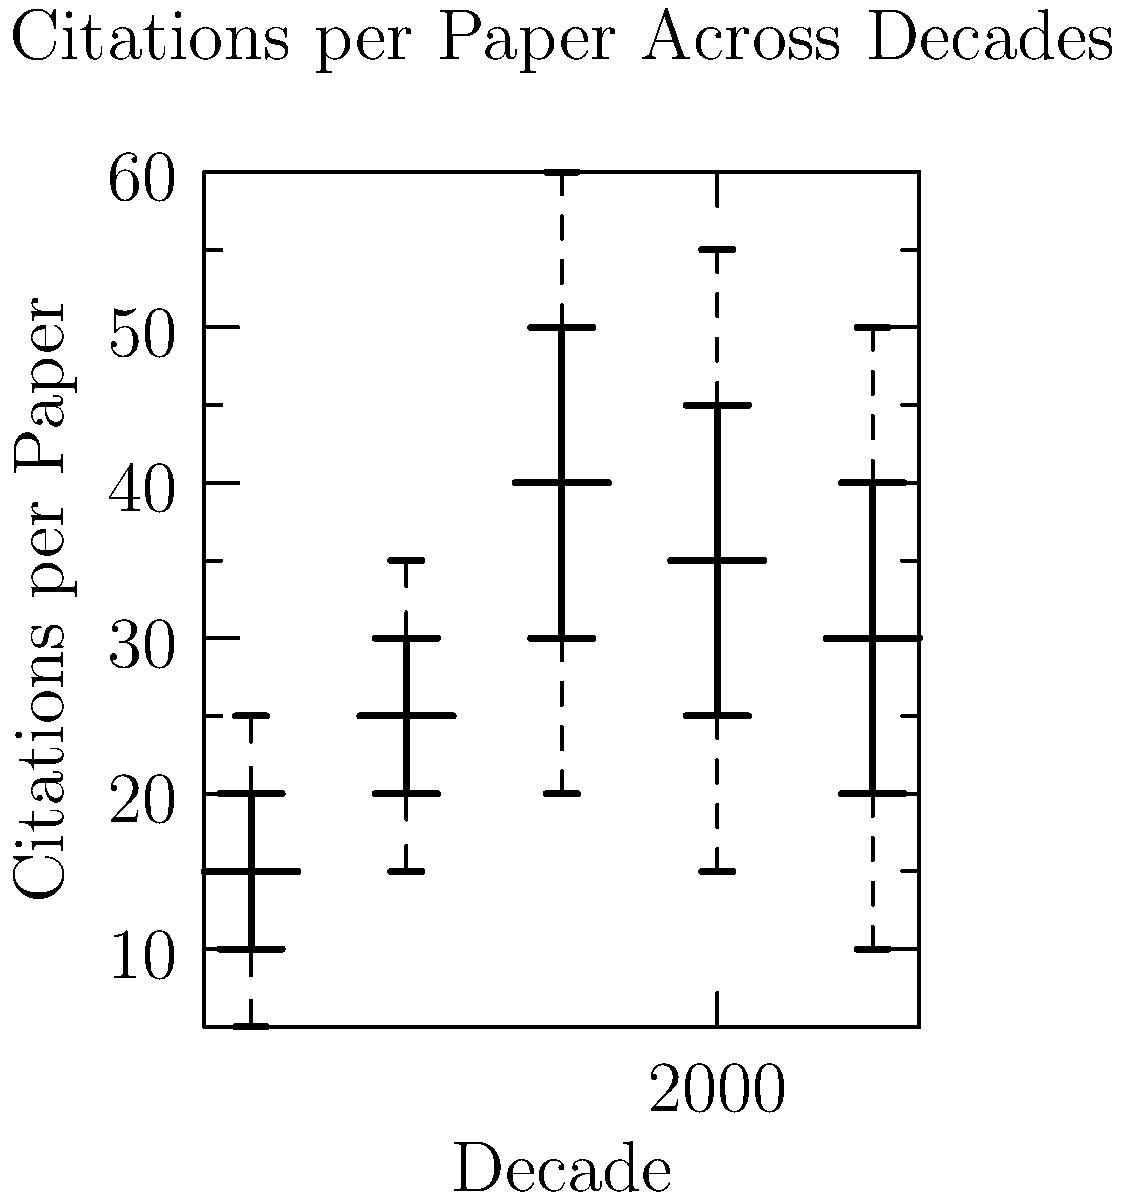Based on the box plot showing the professor's research impact across different decades, which decade shows the highest median number of citations per paper, and what is the interquartile range (IQR) for that decade? To answer this question, we need to follow these steps:

1. Identify the decade with the highest median:
   - 1970s: median ≈ 15
   - 1980s: median ≈ 25
   - 1990s: median ≈ 40
   - 2000s: median ≈ 35
   - 2010s: median ≈ 30

   The highest median is in the 1990s at approximately 40 citations per paper.

2. Calculate the IQR for the 1990s:
   - The IQR is the difference between the third quartile (Q3) and the first quartile (Q1)
   - For the 1990s:
     Q3 ≈ 50
     Q1 ≈ 30
   - IQR = Q3 - Q1 = 50 - 30 = 20

Therefore, the decade with the highest median number of citations per paper is the 1990s, with a median of approximately 40 citations. The IQR for this decade is 20 citations.
Answer: 1990s, IQR = 20 citations 